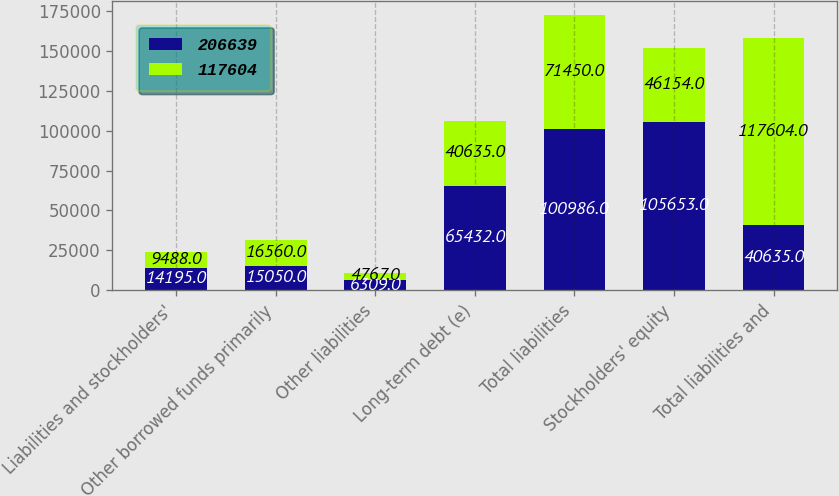Convert chart to OTSL. <chart><loc_0><loc_0><loc_500><loc_500><stacked_bar_chart><ecel><fcel>Liabilities and stockholders'<fcel>Other borrowed funds primarily<fcel>Other liabilities<fcel>Long-term debt (e)<fcel>Total liabilities<fcel>Stockholders' equity<fcel>Total liabilities and<nl><fcel>206639<fcel>14195<fcel>15050<fcel>6309<fcel>65432<fcel>100986<fcel>105653<fcel>40635<nl><fcel>117604<fcel>9488<fcel>16560<fcel>4767<fcel>40635<fcel>71450<fcel>46154<fcel>117604<nl></chart> 